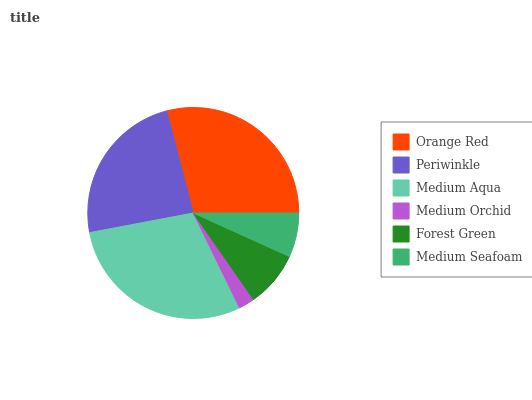Is Medium Orchid the minimum?
Answer yes or no. Yes. Is Medium Aqua the maximum?
Answer yes or no. Yes. Is Periwinkle the minimum?
Answer yes or no. No. Is Periwinkle the maximum?
Answer yes or no. No. Is Orange Red greater than Periwinkle?
Answer yes or no. Yes. Is Periwinkle less than Orange Red?
Answer yes or no. Yes. Is Periwinkle greater than Orange Red?
Answer yes or no. No. Is Orange Red less than Periwinkle?
Answer yes or no. No. Is Periwinkle the high median?
Answer yes or no. Yes. Is Forest Green the low median?
Answer yes or no. Yes. Is Medium Seafoam the high median?
Answer yes or no. No. Is Medium Orchid the low median?
Answer yes or no. No. 